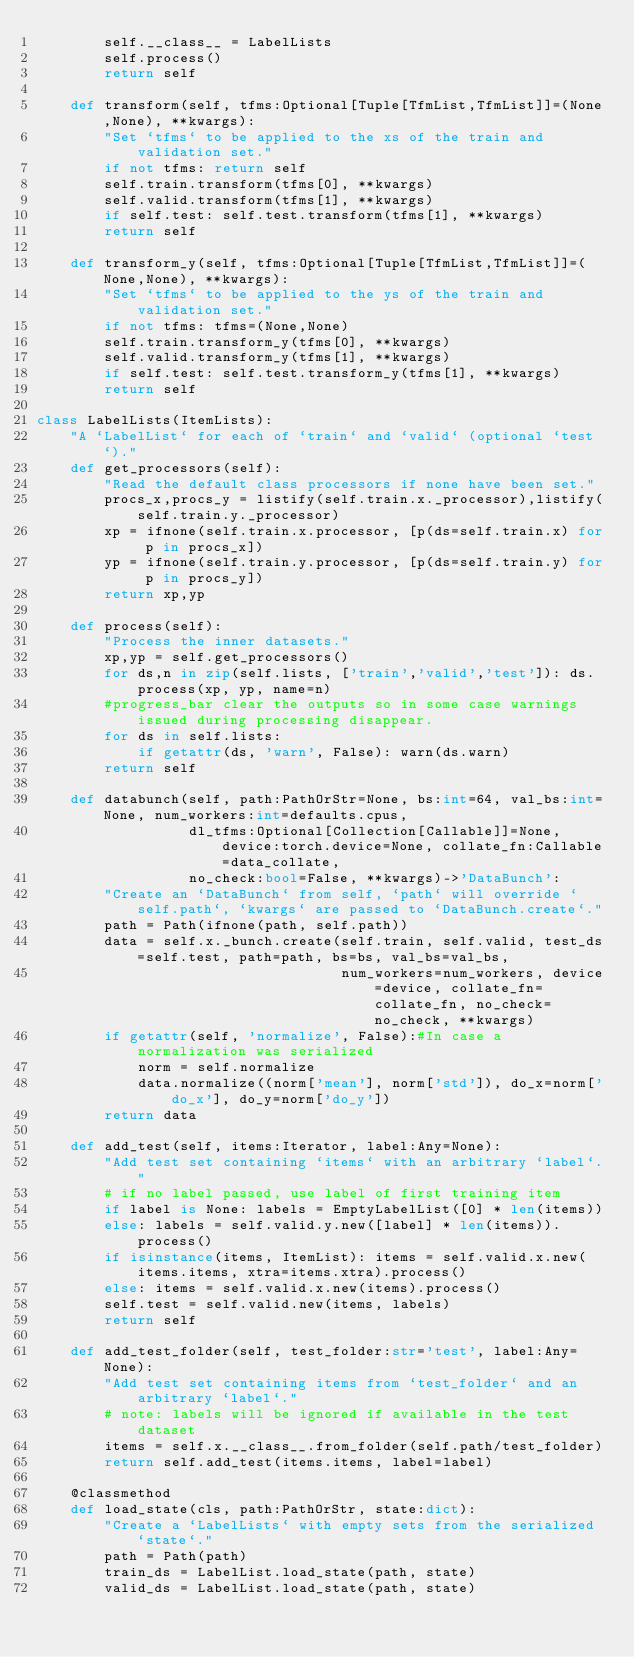<code> <loc_0><loc_0><loc_500><loc_500><_Python_>        self.__class__ = LabelLists
        self.process()
        return self

    def transform(self, tfms:Optional[Tuple[TfmList,TfmList]]=(None,None), **kwargs):
        "Set `tfms` to be applied to the xs of the train and validation set."
        if not tfms: return self
        self.train.transform(tfms[0], **kwargs)
        self.valid.transform(tfms[1], **kwargs)
        if self.test: self.test.transform(tfms[1], **kwargs)
        return self

    def transform_y(self, tfms:Optional[Tuple[TfmList,TfmList]]=(None,None), **kwargs):
        "Set `tfms` to be applied to the ys of the train and validation set."
        if not tfms: tfms=(None,None)
        self.train.transform_y(tfms[0], **kwargs)
        self.valid.transform_y(tfms[1], **kwargs)
        if self.test: self.test.transform_y(tfms[1], **kwargs)
        return self

class LabelLists(ItemLists):
    "A `LabelList` for each of `train` and `valid` (optional `test`)."
    def get_processors(self):
        "Read the default class processors if none have been set."
        procs_x,procs_y = listify(self.train.x._processor),listify(self.train.y._processor)
        xp = ifnone(self.train.x.processor, [p(ds=self.train.x) for p in procs_x])
        yp = ifnone(self.train.y.processor, [p(ds=self.train.y) for p in procs_y])
        return xp,yp

    def process(self):
        "Process the inner datasets."
        xp,yp = self.get_processors()
        for ds,n in zip(self.lists, ['train','valid','test']): ds.process(xp, yp, name=n)
        #progress_bar clear the outputs so in some case warnings issued during processing disappear.
        for ds in self.lists:
            if getattr(ds, 'warn', False): warn(ds.warn)
        return self

    def databunch(self, path:PathOrStr=None, bs:int=64, val_bs:int=None, num_workers:int=defaults.cpus, 
                  dl_tfms:Optional[Collection[Callable]]=None, device:torch.device=None, collate_fn:Callable=data_collate, 
                  no_check:bool=False, **kwargs)->'DataBunch':
        "Create an `DataBunch` from self, `path` will override `self.path`, `kwargs` are passed to `DataBunch.create`."
        path = Path(ifnone(path, self.path))
        data = self.x._bunch.create(self.train, self.valid, test_ds=self.test, path=path, bs=bs, val_bs=val_bs, 
                                    num_workers=num_workers, device=device, collate_fn=collate_fn, no_check=no_check, **kwargs)
        if getattr(self, 'normalize', False):#In case a normalization was serialized
            norm = self.normalize
            data.normalize((norm['mean'], norm['std']), do_x=norm['do_x'], do_y=norm['do_y'])
        return data

    def add_test(self, items:Iterator, label:Any=None):
        "Add test set containing `items` with an arbitrary `label`."
        # if no label passed, use label of first training item
        if label is None: labels = EmptyLabelList([0] * len(items))
        else: labels = self.valid.y.new([label] * len(items)).process()
        if isinstance(items, ItemList): items = self.valid.x.new(items.items, xtra=items.xtra).process()
        else: items = self.valid.x.new(items).process()          
        self.test = self.valid.new(items, labels)
        return self

    def add_test_folder(self, test_folder:str='test', label:Any=None):
        "Add test set containing items from `test_folder` and an arbitrary `label`."
        # note: labels will be ignored if available in the test dataset
        items = self.x.__class__.from_folder(self.path/test_folder)
        return self.add_test(items.items, label=label)
                
    @classmethod
    def load_state(cls, path:PathOrStr, state:dict):
        "Create a `LabelLists` with empty sets from the serialized `state`."
        path = Path(path)
        train_ds = LabelList.load_state(path, state)
        valid_ds = LabelList.load_state(path, state)</code> 